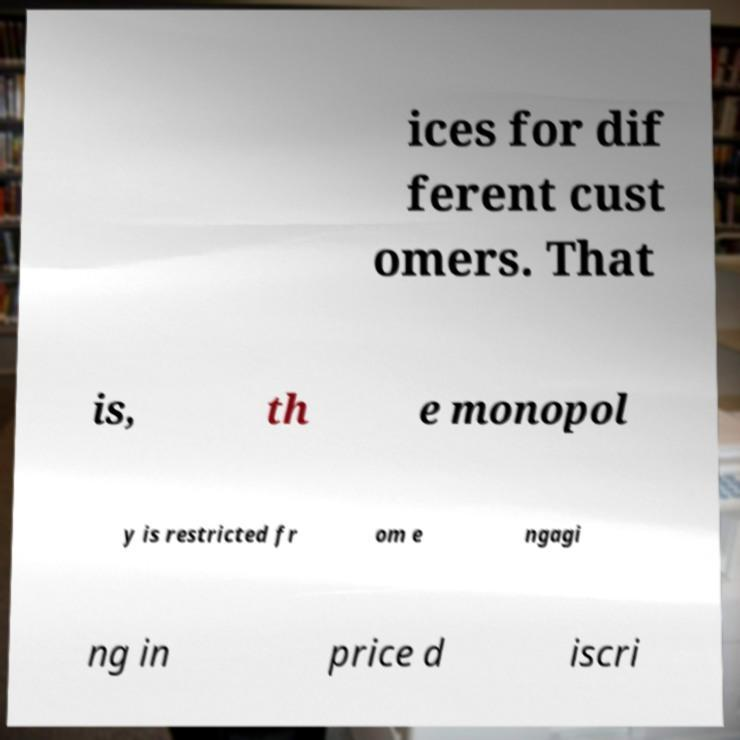Can you accurately transcribe the text from the provided image for me? ices for dif ferent cust omers. That is, th e monopol y is restricted fr om e ngagi ng in price d iscri 